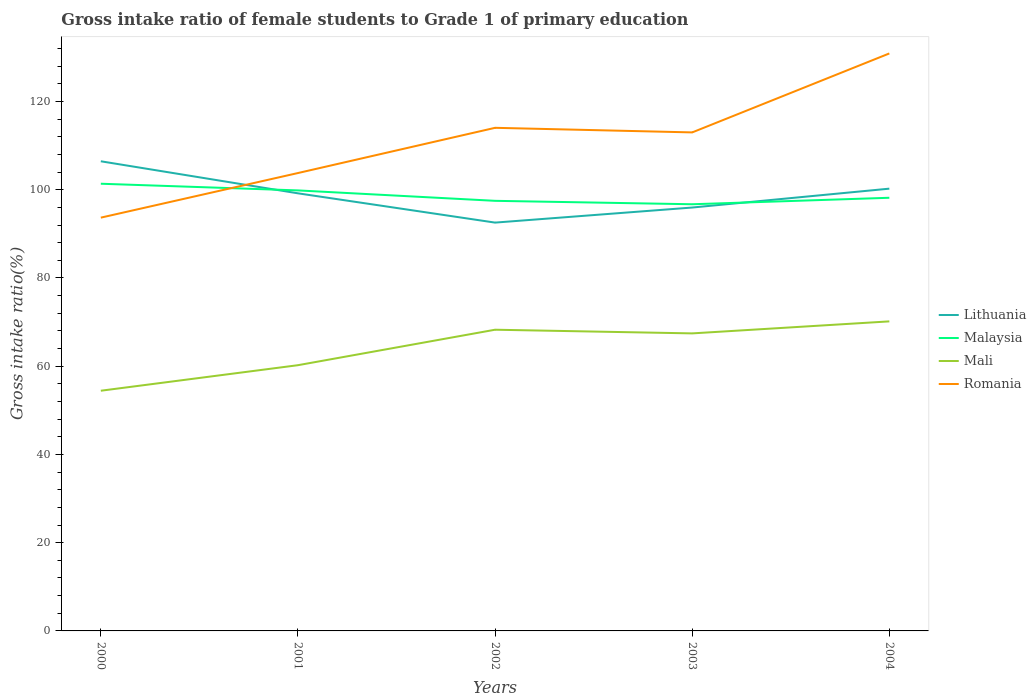How many different coloured lines are there?
Your response must be concise. 4. Does the line corresponding to Malaysia intersect with the line corresponding to Lithuania?
Your response must be concise. Yes. Is the number of lines equal to the number of legend labels?
Your answer should be compact. Yes. Across all years, what is the maximum gross intake ratio in Lithuania?
Provide a succinct answer. 92.55. In which year was the gross intake ratio in Lithuania maximum?
Your answer should be compact. 2002. What is the total gross intake ratio in Romania in the graph?
Provide a succinct answer. -19.32. What is the difference between the highest and the second highest gross intake ratio in Mali?
Provide a short and direct response. 15.72. What is the difference between the highest and the lowest gross intake ratio in Mali?
Keep it short and to the point. 3. What is the difference between two consecutive major ticks on the Y-axis?
Keep it short and to the point. 20. Where does the legend appear in the graph?
Make the answer very short. Center right. What is the title of the graph?
Ensure brevity in your answer.  Gross intake ratio of female students to Grade 1 of primary education. Does "Costa Rica" appear as one of the legend labels in the graph?
Provide a short and direct response. No. What is the label or title of the X-axis?
Your answer should be compact. Years. What is the label or title of the Y-axis?
Offer a terse response. Gross intake ratio(%). What is the Gross intake ratio(%) of Lithuania in 2000?
Ensure brevity in your answer.  106.45. What is the Gross intake ratio(%) of Malaysia in 2000?
Provide a succinct answer. 101.36. What is the Gross intake ratio(%) of Mali in 2000?
Your answer should be compact. 54.44. What is the Gross intake ratio(%) of Romania in 2000?
Ensure brevity in your answer.  93.67. What is the Gross intake ratio(%) of Lithuania in 2001?
Make the answer very short. 99.19. What is the Gross intake ratio(%) of Malaysia in 2001?
Make the answer very short. 99.85. What is the Gross intake ratio(%) in Mali in 2001?
Offer a very short reply. 60.23. What is the Gross intake ratio(%) in Romania in 2001?
Your response must be concise. 103.78. What is the Gross intake ratio(%) of Lithuania in 2002?
Provide a short and direct response. 92.55. What is the Gross intake ratio(%) of Malaysia in 2002?
Your answer should be compact. 97.48. What is the Gross intake ratio(%) of Mali in 2002?
Offer a terse response. 68.27. What is the Gross intake ratio(%) of Romania in 2002?
Provide a succinct answer. 114.03. What is the Gross intake ratio(%) in Lithuania in 2003?
Your response must be concise. 95.96. What is the Gross intake ratio(%) of Malaysia in 2003?
Offer a very short reply. 96.71. What is the Gross intake ratio(%) in Mali in 2003?
Offer a terse response. 67.44. What is the Gross intake ratio(%) of Romania in 2003?
Your response must be concise. 112.99. What is the Gross intake ratio(%) of Lithuania in 2004?
Ensure brevity in your answer.  100.24. What is the Gross intake ratio(%) in Malaysia in 2004?
Give a very brief answer. 98.18. What is the Gross intake ratio(%) of Mali in 2004?
Ensure brevity in your answer.  70.16. What is the Gross intake ratio(%) of Romania in 2004?
Keep it short and to the point. 130.89. Across all years, what is the maximum Gross intake ratio(%) of Lithuania?
Offer a terse response. 106.45. Across all years, what is the maximum Gross intake ratio(%) in Malaysia?
Give a very brief answer. 101.36. Across all years, what is the maximum Gross intake ratio(%) of Mali?
Offer a terse response. 70.16. Across all years, what is the maximum Gross intake ratio(%) of Romania?
Keep it short and to the point. 130.89. Across all years, what is the minimum Gross intake ratio(%) in Lithuania?
Your answer should be compact. 92.55. Across all years, what is the minimum Gross intake ratio(%) in Malaysia?
Your answer should be compact. 96.71. Across all years, what is the minimum Gross intake ratio(%) of Mali?
Ensure brevity in your answer.  54.44. Across all years, what is the minimum Gross intake ratio(%) in Romania?
Provide a short and direct response. 93.67. What is the total Gross intake ratio(%) in Lithuania in the graph?
Your response must be concise. 494.39. What is the total Gross intake ratio(%) in Malaysia in the graph?
Offer a terse response. 493.57. What is the total Gross intake ratio(%) in Mali in the graph?
Your response must be concise. 320.54. What is the total Gross intake ratio(%) in Romania in the graph?
Your answer should be compact. 555.37. What is the difference between the Gross intake ratio(%) in Lithuania in 2000 and that in 2001?
Give a very brief answer. 7.26. What is the difference between the Gross intake ratio(%) in Malaysia in 2000 and that in 2001?
Keep it short and to the point. 1.51. What is the difference between the Gross intake ratio(%) of Mali in 2000 and that in 2001?
Your answer should be compact. -5.79. What is the difference between the Gross intake ratio(%) in Romania in 2000 and that in 2001?
Your answer should be very brief. -10.11. What is the difference between the Gross intake ratio(%) in Lithuania in 2000 and that in 2002?
Give a very brief answer. 13.9. What is the difference between the Gross intake ratio(%) of Malaysia in 2000 and that in 2002?
Make the answer very short. 3.87. What is the difference between the Gross intake ratio(%) of Mali in 2000 and that in 2002?
Provide a short and direct response. -13.83. What is the difference between the Gross intake ratio(%) in Romania in 2000 and that in 2002?
Provide a short and direct response. -20.36. What is the difference between the Gross intake ratio(%) of Lithuania in 2000 and that in 2003?
Your answer should be very brief. 10.48. What is the difference between the Gross intake ratio(%) of Malaysia in 2000 and that in 2003?
Ensure brevity in your answer.  4.65. What is the difference between the Gross intake ratio(%) in Mali in 2000 and that in 2003?
Keep it short and to the point. -12.99. What is the difference between the Gross intake ratio(%) in Romania in 2000 and that in 2003?
Give a very brief answer. -19.32. What is the difference between the Gross intake ratio(%) of Lithuania in 2000 and that in 2004?
Your response must be concise. 6.21. What is the difference between the Gross intake ratio(%) of Malaysia in 2000 and that in 2004?
Provide a succinct answer. 3.18. What is the difference between the Gross intake ratio(%) of Mali in 2000 and that in 2004?
Provide a short and direct response. -15.72. What is the difference between the Gross intake ratio(%) in Romania in 2000 and that in 2004?
Offer a very short reply. -37.22. What is the difference between the Gross intake ratio(%) of Lithuania in 2001 and that in 2002?
Your answer should be very brief. 6.64. What is the difference between the Gross intake ratio(%) of Malaysia in 2001 and that in 2002?
Provide a succinct answer. 2.36. What is the difference between the Gross intake ratio(%) of Mali in 2001 and that in 2002?
Keep it short and to the point. -8.04. What is the difference between the Gross intake ratio(%) in Romania in 2001 and that in 2002?
Your answer should be very brief. -10.25. What is the difference between the Gross intake ratio(%) of Lithuania in 2001 and that in 2003?
Provide a succinct answer. 3.22. What is the difference between the Gross intake ratio(%) in Malaysia in 2001 and that in 2003?
Offer a terse response. 3.14. What is the difference between the Gross intake ratio(%) in Mali in 2001 and that in 2003?
Make the answer very short. -7.21. What is the difference between the Gross intake ratio(%) in Romania in 2001 and that in 2003?
Provide a succinct answer. -9.21. What is the difference between the Gross intake ratio(%) in Lithuania in 2001 and that in 2004?
Ensure brevity in your answer.  -1.06. What is the difference between the Gross intake ratio(%) of Malaysia in 2001 and that in 2004?
Ensure brevity in your answer.  1.67. What is the difference between the Gross intake ratio(%) of Mali in 2001 and that in 2004?
Your answer should be compact. -9.93. What is the difference between the Gross intake ratio(%) of Romania in 2001 and that in 2004?
Offer a very short reply. -27.11. What is the difference between the Gross intake ratio(%) in Lithuania in 2002 and that in 2003?
Offer a very short reply. -3.42. What is the difference between the Gross intake ratio(%) of Malaysia in 2002 and that in 2003?
Keep it short and to the point. 0.78. What is the difference between the Gross intake ratio(%) in Mali in 2002 and that in 2003?
Your answer should be compact. 0.83. What is the difference between the Gross intake ratio(%) in Romania in 2002 and that in 2003?
Ensure brevity in your answer.  1.04. What is the difference between the Gross intake ratio(%) in Lithuania in 2002 and that in 2004?
Provide a succinct answer. -7.69. What is the difference between the Gross intake ratio(%) in Malaysia in 2002 and that in 2004?
Provide a short and direct response. -0.69. What is the difference between the Gross intake ratio(%) of Mali in 2002 and that in 2004?
Provide a short and direct response. -1.89. What is the difference between the Gross intake ratio(%) in Romania in 2002 and that in 2004?
Make the answer very short. -16.86. What is the difference between the Gross intake ratio(%) of Lithuania in 2003 and that in 2004?
Your answer should be compact. -4.28. What is the difference between the Gross intake ratio(%) in Malaysia in 2003 and that in 2004?
Provide a succinct answer. -1.47. What is the difference between the Gross intake ratio(%) of Mali in 2003 and that in 2004?
Keep it short and to the point. -2.72. What is the difference between the Gross intake ratio(%) of Romania in 2003 and that in 2004?
Provide a short and direct response. -17.9. What is the difference between the Gross intake ratio(%) of Lithuania in 2000 and the Gross intake ratio(%) of Malaysia in 2001?
Make the answer very short. 6.6. What is the difference between the Gross intake ratio(%) of Lithuania in 2000 and the Gross intake ratio(%) of Mali in 2001?
Make the answer very short. 46.22. What is the difference between the Gross intake ratio(%) of Lithuania in 2000 and the Gross intake ratio(%) of Romania in 2001?
Provide a succinct answer. 2.66. What is the difference between the Gross intake ratio(%) of Malaysia in 2000 and the Gross intake ratio(%) of Mali in 2001?
Offer a very short reply. 41.13. What is the difference between the Gross intake ratio(%) of Malaysia in 2000 and the Gross intake ratio(%) of Romania in 2001?
Give a very brief answer. -2.42. What is the difference between the Gross intake ratio(%) in Mali in 2000 and the Gross intake ratio(%) in Romania in 2001?
Give a very brief answer. -49.34. What is the difference between the Gross intake ratio(%) of Lithuania in 2000 and the Gross intake ratio(%) of Malaysia in 2002?
Your answer should be very brief. 8.96. What is the difference between the Gross intake ratio(%) of Lithuania in 2000 and the Gross intake ratio(%) of Mali in 2002?
Your answer should be compact. 38.18. What is the difference between the Gross intake ratio(%) in Lithuania in 2000 and the Gross intake ratio(%) in Romania in 2002?
Your answer should be very brief. -7.58. What is the difference between the Gross intake ratio(%) in Malaysia in 2000 and the Gross intake ratio(%) in Mali in 2002?
Ensure brevity in your answer.  33.09. What is the difference between the Gross intake ratio(%) in Malaysia in 2000 and the Gross intake ratio(%) in Romania in 2002?
Keep it short and to the point. -12.67. What is the difference between the Gross intake ratio(%) in Mali in 2000 and the Gross intake ratio(%) in Romania in 2002?
Keep it short and to the point. -59.59. What is the difference between the Gross intake ratio(%) in Lithuania in 2000 and the Gross intake ratio(%) in Malaysia in 2003?
Your answer should be very brief. 9.74. What is the difference between the Gross intake ratio(%) in Lithuania in 2000 and the Gross intake ratio(%) in Mali in 2003?
Offer a terse response. 39.01. What is the difference between the Gross intake ratio(%) in Lithuania in 2000 and the Gross intake ratio(%) in Romania in 2003?
Make the answer very short. -6.54. What is the difference between the Gross intake ratio(%) in Malaysia in 2000 and the Gross intake ratio(%) in Mali in 2003?
Provide a short and direct response. 33.92. What is the difference between the Gross intake ratio(%) in Malaysia in 2000 and the Gross intake ratio(%) in Romania in 2003?
Make the answer very short. -11.63. What is the difference between the Gross intake ratio(%) in Mali in 2000 and the Gross intake ratio(%) in Romania in 2003?
Offer a very short reply. -58.55. What is the difference between the Gross intake ratio(%) in Lithuania in 2000 and the Gross intake ratio(%) in Malaysia in 2004?
Provide a short and direct response. 8.27. What is the difference between the Gross intake ratio(%) in Lithuania in 2000 and the Gross intake ratio(%) in Mali in 2004?
Make the answer very short. 36.29. What is the difference between the Gross intake ratio(%) in Lithuania in 2000 and the Gross intake ratio(%) in Romania in 2004?
Give a very brief answer. -24.44. What is the difference between the Gross intake ratio(%) in Malaysia in 2000 and the Gross intake ratio(%) in Mali in 2004?
Offer a terse response. 31.2. What is the difference between the Gross intake ratio(%) in Malaysia in 2000 and the Gross intake ratio(%) in Romania in 2004?
Provide a succinct answer. -29.53. What is the difference between the Gross intake ratio(%) in Mali in 2000 and the Gross intake ratio(%) in Romania in 2004?
Make the answer very short. -76.45. What is the difference between the Gross intake ratio(%) of Lithuania in 2001 and the Gross intake ratio(%) of Malaysia in 2002?
Give a very brief answer. 1.7. What is the difference between the Gross intake ratio(%) of Lithuania in 2001 and the Gross intake ratio(%) of Mali in 2002?
Offer a very short reply. 30.92. What is the difference between the Gross intake ratio(%) in Lithuania in 2001 and the Gross intake ratio(%) in Romania in 2002?
Provide a succinct answer. -14.85. What is the difference between the Gross intake ratio(%) in Malaysia in 2001 and the Gross intake ratio(%) in Mali in 2002?
Ensure brevity in your answer.  31.58. What is the difference between the Gross intake ratio(%) in Malaysia in 2001 and the Gross intake ratio(%) in Romania in 2002?
Provide a short and direct response. -14.19. What is the difference between the Gross intake ratio(%) in Mali in 2001 and the Gross intake ratio(%) in Romania in 2002?
Give a very brief answer. -53.8. What is the difference between the Gross intake ratio(%) of Lithuania in 2001 and the Gross intake ratio(%) of Malaysia in 2003?
Give a very brief answer. 2.48. What is the difference between the Gross intake ratio(%) of Lithuania in 2001 and the Gross intake ratio(%) of Mali in 2003?
Your answer should be compact. 31.75. What is the difference between the Gross intake ratio(%) in Lithuania in 2001 and the Gross intake ratio(%) in Romania in 2003?
Provide a succinct answer. -13.81. What is the difference between the Gross intake ratio(%) in Malaysia in 2001 and the Gross intake ratio(%) in Mali in 2003?
Make the answer very short. 32.41. What is the difference between the Gross intake ratio(%) of Malaysia in 2001 and the Gross intake ratio(%) of Romania in 2003?
Your answer should be compact. -13.15. What is the difference between the Gross intake ratio(%) of Mali in 2001 and the Gross intake ratio(%) of Romania in 2003?
Ensure brevity in your answer.  -52.76. What is the difference between the Gross intake ratio(%) of Lithuania in 2001 and the Gross intake ratio(%) of Malaysia in 2004?
Your response must be concise. 1.01. What is the difference between the Gross intake ratio(%) in Lithuania in 2001 and the Gross intake ratio(%) in Mali in 2004?
Offer a very short reply. 29.02. What is the difference between the Gross intake ratio(%) of Lithuania in 2001 and the Gross intake ratio(%) of Romania in 2004?
Ensure brevity in your answer.  -31.7. What is the difference between the Gross intake ratio(%) in Malaysia in 2001 and the Gross intake ratio(%) in Mali in 2004?
Keep it short and to the point. 29.69. What is the difference between the Gross intake ratio(%) in Malaysia in 2001 and the Gross intake ratio(%) in Romania in 2004?
Make the answer very short. -31.04. What is the difference between the Gross intake ratio(%) of Mali in 2001 and the Gross intake ratio(%) of Romania in 2004?
Make the answer very short. -70.66. What is the difference between the Gross intake ratio(%) in Lithuania in 2002 and the Gross intake ratio(%) in Malaysia in 2003?
Keep it short and to the point. -4.16. What is the difference between the Gross intake ratio(%) of Lithuania in 2002 and the Gross intake ratio(%) of Mali in 2003?
Your response must be concise. 25.11. What is the difference between the Gross intake ratio(%) of Lithuania in 2002 and the Gross intake ratio(%) of Romania in 2003?
Your answer should be compact. -20.44. What is the difference between the Gross intake ratio(%) of Malaysia in 2002 and the Gross intake ratio(%) of Mali in 2003?
Give a very brief answer. 30.05. What is the difference between the Gross intake ratio(%) of Malaysia in 2002 and the Gross intake ratio(%) of Romania in 2003?
Provide a succinct answer. -15.51. What is the difference between the Gross intake ratio(%) of Mali in 2002 and the Gross intake ratio(%) of Romania in 2003?
Offer a very short reply. -44.72. What is the difference between the Gross intake ratio(%) of Lithuania in 2002 and the Gross intake ratio(%) of Malaysia in 2004?
Your answer should be very brief. -5.63. What is the difference between the Gross intake ratio(%) of Lithuania in 2002 and the Gross intake ratio(%) of Mali in 2004?
Provide a short and direct response. 22.39. What is the difference between the Gross intake ratio(%) of Lithuania in 2002 and the Gross intake ratio(%) of Romania in 2004?
Keep it short and to the point. -38.34. What is the difference between the Gross intake ratio(%) of Malaysia in 2002 and the Gross intake ratio(%) of Mali in 2004?
Make the answer very short. 27.32. What is the difference between the Gross intake ratio(%) in Malaysia in 2002 and the Gross intake ratio(%) in Romania in 2004?
Your answer should be compact. -33.41. What is the difference between the Gross intake ratio(%) in Mali in 2002 and the Gross intake ratio(%) in Romania in 2004?
Provide a short and direct response. -62.62. What is the difference between the Gross intake ratio(%) in Lithuania in 2003 and the Gross intake ratio(%) in Malaysia in 2004?
Give a very brief answer. -2.21. What is the difference between the Gross intake ratio(%) of Lithuania in 2003 and the Gross intake ratio(%) of Mali in 2004?
Your answer should be compact. 25.8. What is the difference between the Gross intake ratio(%) in Lithuania in 2003 and the Gross intake ratio(%) in Romania in 2004?
Keep it short and to the point. -34.93. What is the difference between the Gross intake ratio(%) of Malaysia in 2003 and the Gross intake ratio(%) of Mali in 2004?
Make the answer very short. 26.55. What is the difference between the Gross intake ratio(%) in Malaysia in 2003 and the Gross intake ratio(%) in Romania in 2004?
Make the answer very short. -34.18. What is the difference between the Gross intake ratio(%) in Mali in 2003 and the Gross intake ratio(%) in Romania in 2004?
Your response must be concise. -63.45. What is the average Gross intake ratio(%) in Lithuania per year?
Offer a terse response. 98.88. What is the average Gross intake ratio(%) of Malaysia per year?
Provide a short and direct response. 98.71. What is the average Gross intake ratio(%) of Mali per year?
Make the answer very short. 64.11. What is the average Gross intake ratio(%) in Romania per year?
Your answer should be compact. 111.07. In the year 2000, what is the difference between the Gross intake ratio(%) in Lithuania and Gross intake ratio(%) in Malaysia?
Keep it short and to the point. 5.09. In the year 2000, what is the difference between the Gross intake ratio(%) of Lithuania and Gross intake ratio(%) of Mali?
Ensure brevity in your answer.  52. In the year 2000, what is the difference between the Gross intake ratio(%) of Lithuania and Gross intake ratio(%) of Romania?
Your answer should be very brief. 12.77. In the year 2000, what is the difference between the Gross intake ratio(%) in Malaysia and Gross intake ratio(%) in Mali?
Provide a short and direct response. 46.91. In the year 2000, what is the difference between the Gross intake ratio(%) of Malaysia and Gross intake ratio(%) of Romania?
Keep it short and to the point. 7.69. In the year 2000, what is the difference between the Gross intake ratio(%) in Mali and Gross intake ratio(%) in Romania?
Ensure brevity in your answer.  -39.23. In the year 2001, what is the difference between the Gross intake ratio(%) in Lithuania and Gross intake ratio(%) in Malaysia?
Provide a short and direct response. -0.66. In the year 2001, what is the difference between the Gross intake ratio(%) in Lithuania and Gross intake ratio(%) in Mali?
Your answer should be very brief. 38.96. In the year 2001, what is the difference between the Gross intake ratio(%) of Lithuania and Gross intake ratio(%) of Romania?
Your response must be concise. -4.6. In the year 2001, what is the difference between the Gross intake ratio(%) of Malaysia and Gross intake ratio(%) of Mali?
Ensure brevity in your answer.  39.62. In the year 2001, what is the difference between the Gross intake ratio(%) in Malaysia and Gross intake ratio(%) in Romania?
Provide a short and direct response. -3.94. In the year 2001, what is the difference between the Gross intake ratio(%) of Mali and Gross intake ratio(%) of Romania?
Your answer should be very brief. -43.55. In the year 2002, what is the difference between the Gross intake ratio(%) of Lithuania and Gross intake ratio(%) of Malaysia?
Make the answer very short. -4.94. In the year 2002, what is the difference between the Gross intake ratio(%) of Lithuania and Gross intake ratio(%) of Mali?
Make the answer very short. 24.28. In the year 2002, what is the difference between the Gross intake ratio(%) in Lithuania and Gross intake ratio(%) in Romania?
Ensure brevity in your answer.  -21.48. In the year 2002, what is the difference between the Gross intake ratio(%) in Malaysia and Gross intake ratio(%) in Mali?
Provide a short and direct response. 29.21. In the year 2002, what is the difference between the Gross intake ratio(%) in Malaysia and Gross intake ratio(%) in Romania?
Your answer should be compact. -16.55. In the year 2002, what is the difference between the Gross intake ratio(%) in Mali and Gross intake ratio(%) in Romania?
Give a very brief answer. -45.76. In the year 2003, what is the difference between the Gross intake ratio(%) in Lithuania and Gross intake ratio(%) in Malaysia?
Give a very brief answer. -0.74. In the year 2003, what is the difference between the Gross intake ratio(%) of Lithuania and Gross intake ratio(%) of Mali?
Your response must be concise. 28.53. In the year 2003, what is the difference between the Gross intake ratio(%) in Lithuania and Gross intake ratio(%) in Romania?
Ensure brevity in your answer.  -17.03. In the year 2003, what is the difference between the Gross intake ratio(%) of Malaysia and Gross intake ratio(%) of Mali?
Your response must be concise. 29.27. In the year 2003, what is the difference between the Gross intake ratio(%) in Malaysia and Gross intake ratio(%) in Romania?
Your answer should be very brief. -16.28. In the year 2003, what is the difference between the Gross intake ratio(%) of Mali and Gross intake ratio(%) of Romania?
Provide a short and direct response. -45.56. In the year 2004, what is the difference between the Gross intake ratio(%) of Lithuania and Gross intake ratio(%) of Malaysia?
Provide a short and direct response. 2.06. In the year 2004, what is the difference between the Gross intake ratio(%) of Lithuania and Gross intake ratio(%) of Mali?
Your answer should be very brief. 30.08. In the year 2004, what is the difference between the Gross intake ratio(%) in Lithuania and Gross intake ratio(%) in Romania?
Your answer should be compact. -30.65. In the year 2004, what is the difference between the Gross intake ratio(%) in Malaysia and Gross intake ratio(%) in Mali?
Your answer should be compact. 28.02. In the year 2004, what is the difference between the Gross intake ratio(%) of Malaysia and Gross intake ratio(%) of Romania?
Ensure brevity in your answer.  -32.71. In the year 2004, what is the difference between the Gross intake ratio(%) in Mali and Gross intake ratio(%) in Romania?
Provide a short and direct response. -60.73. What is the ratio of the Gross intake ratio(%) of Lithuania in 2000 to that in 2001?
Offer a very short reply. 1.07. What is the ratio of the Gross intake ratio(%) in Malaysia in 2000 to that in 2001?
Make the answer very short. 1.02. What is the ratio of the Gross intake ratio(%) of Mali in 2000 to that in 2001?
Your answer should be very brief. 0.9. What is the ratio of the Gross intake ratio(%) in Romania in 2000 to that in 2001?
Your response must be concise. 0.9. What is the ratio of the Gross intake ratio(%) in Lithuania in 2000 to that in 2002?
Make the answer very short. 1.15. What is the ratio of the Gross intake ratio(%) of Malaysia in 2000 to that in 2002?
Ensure brevity in your answer.  1.04. What is the ratio of the Gross intake ratio(%) of Mali in 2000 to that in 2002?
Ensure brevity in your answer.  0.8. What is the ratio of the Gross intake ratio(%) of Romania in 2000 to that in 2002?
Your response must be concise. 0.82. What is the ratio of the Gross intake ratio(%) of Lithuania in 2000 to that in 2003?
Your response must be concise. 1.11. What is the ratio of the Gross intake ratio(%) in Malaysia in 2000 to that in 2003?
Provide a short and direct response. 1.05. What is the ratio of the Gross intake ratio(%) in Mali in 2000 to that in 2003?
Your answer should be compact. 0.81. What is the ratio of the Gross intake ratio(%) of Romania in 2000 to that in 2003?
Make the answer very short. 0.83. What is the ratio of the Gross intake ratio(%) in Lithuania in 2000 to that in 2004?
Offer a terse response. 1.06. What is the ratio of the Gross intake ratio(%) of Malaysia in 2000 to that in 2004?
Give a very brief answer. 1.03. What is the ratio of the Gross intake ratio(%) in Mali in 2000 to that in 2004?
Offer a terse response. 0.78. What is the ratio of the Gross intake ratio(%) of Romania in 2000 to that in 2004?
Give a very brief answer. 0.72. What is the ratio of the Gross intake ratio(%) in Lithuania in 2001 to that in 2002?
Ensure brevity in your answer.  1.07. What is the ratio of the Gross intake ratio(%) in Malaysia in 2001 to that in 2002?
Your answer should be very brief. 1.02. What is the ratio of the Gross intake ratio(%) in Mali in 2001 to that in 2002?
Your answer should be very brief. 0.88. What is the ratio of the Gross intake ratio(%) of Romania in 2001 to that in 2002?
Your response must be concise. 0.91. What is the ratio of the Gross intake ratio(%) of Lithuania in 2001 to that in 2003?
Your answer should be very brief. 1.03. What is the ratio of the Gross intake ratio(%) in Malaysia in 2001 to that in 2003?
Your answer should be very brief. 1.03. What is the ratio of the Gross intake ratio(%) in Mali in 2001 to that in 2003?
Ensure brevity in your answer.  0.89. What is the ratio of the Gross intake ratio(%) of Romania in 2001 to that in 2003?
Make the answer very short. 0.92. What is the ratio of the Gross intake ratio(%) in Mali in 2001 to that in 2004?
Make the answer very short. 0.86. What is the ratio of the Gross intake ratio(%) of Romania in 2001 to that in 2004?
Make the answer very short. 0.79. What is the ratio of the Gross intake ratio(%) of Lithuania in 2002 to that in 2003?
Ensure brevity in your answer.  0.96. What is the ratio of the Gross intake ratio(%) in Mali in 2002 to that in 2003?
Provide a succinct answer. 1.01. What is the ratio of the Gross intake ratio(%) in Romania in 2002 to that in 2003?
Keep it short and to the point. 1.01. What is the ratio of the Gross intake ratio(%) of Lithuania in 2002 to that in 2004?
Ensure brevity in your answer.  0.92. What is the ratio of the Gross intake ratio(%) of Malaysia in 2002 to that in 2004?
Your answer should be very brief. 0.99. What is the ratio of the Gross intake ratio(%) in Romania in 2002 to that in 2004?
Provide a succinct answer. 0.87. What is the ratio of the Gross intake ratio(%) in Lithuania in 2003 to that in 2004?
Make the answer very short. 0.96. What is the ratio of the Gross intake ratio(%) in Malaysia in 2003 to that in 2004?
Offer a very short reply. 0.98. What is the ratio of the Gross intake ratio(%) of Mali in 2003 to that in 2004?
Offer a very short reply. 0.96. What is the ratio of the Gross intake ratio(%) of Romania in 2003 to that in 2004?
Make the answer very short. 0.86. What is the difference between the highest and the second highest Gross intake ratio(%) in Lithuania?
Offer a very short reply. 6.21. What is the difference between the highest and the second highest Gross intake ratio(%) of Malaysia?
Provide a succinct answer. 1.51. What is the difference between the highest and the second highest Gross intake ratio(%) of Mali?
Your response must be concise. 1.89. What is the difference between the highest and the second highest Gross intake ratio(%) in Romania?
Ensure brevity in your answer.  16.86. What is the difference between the highest and the lowest Gross intake ratio(%) of Lithuania?
Ensure brevity in your answer.  13.9. What is the difference between the highest and the lowest Gross intake ratio(%) of Malaysia?
Keep it short and to the point. 4.65. What is the difference between the highest and the lowest Gross intake ratio(%) in Mali?
Your response must be concise. 15.72. What is the difference between the highest and the lowest Gross intake ratio(%) in Romania?
Ensure brevity in your answer.  37.22. 